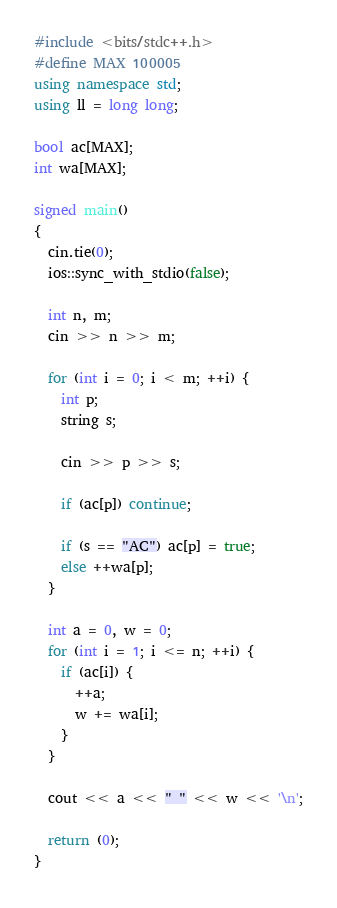Convert code to text. <code><loc_0><loc_0><loc_500><loc_500><_C++_>#include <bits/stdc++.h>
#define MAX 100005
using namespace std;
using ll = long long;

bool ac[MAX];
int wa[MAX];

signed main()
{
  cin.tie(0);
  ios::sync_with_stdio(false);

  int n, m;
  cin >> n >> m;

  for (int i = 0; i < m; ++i) {
    int p;
    string s;
    
    cin >> p >> s;

    if (ac[p]) continue;
  
    if (s == "AC") ac[p] = true;
    else ++wa[p];
  }

  int a = 0, w = 0;
  for (int i = 1; i <= n; ++i) {
    if (ac[i]) {
      ++a;
      w += wa[i];
    }
  }

  cout << a << " " << w << '\n';

  return (0);
}
</code> 